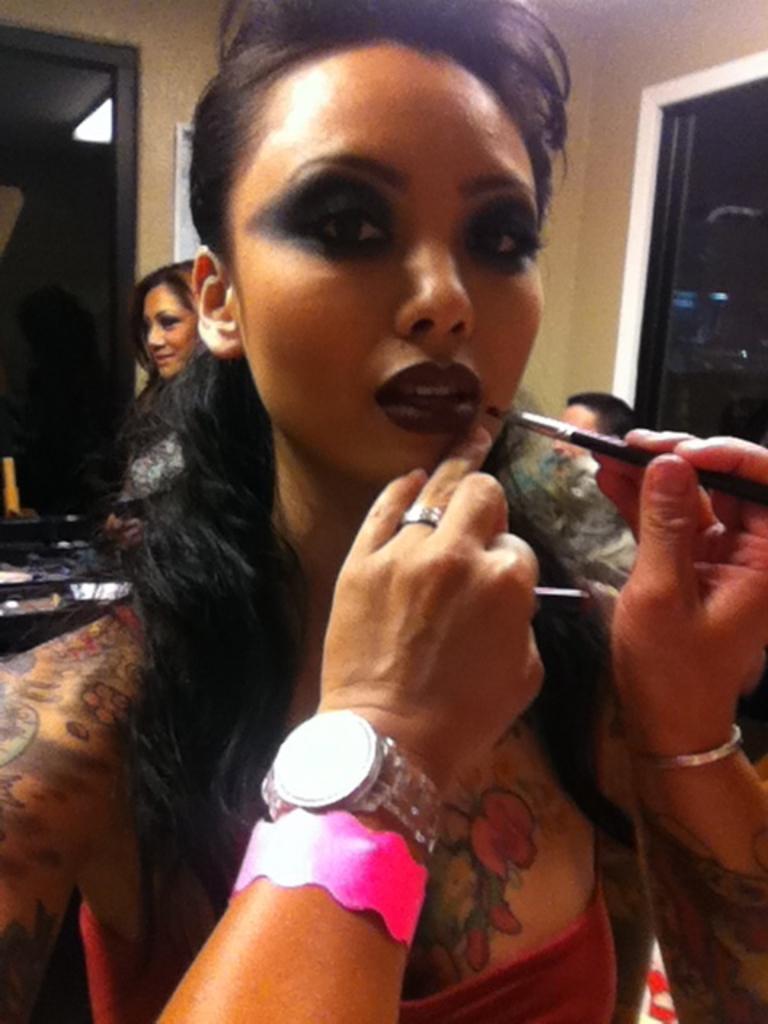Could you give a brief overview of what you see in this image? In this picture there is a woman who is painted her body. Beside her we can see a person who is wearing watch, ring, bracelet and holding a brush. In the background there is another woman who is standing near to the wall. On the right background there is a man who is standing near to the door. 